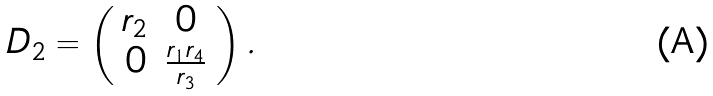Convert formula to latex. <formula><loc_0><loc_0><loc_500><loc_500>D _ { 2 } = \left ( \begin{array} { c c } r _ { 2 } & 0 \\ 0 & \frac { r _ { 1 } r _ { 4 } } { r _ { 3 } } \end{array} \right ) .</formula> 